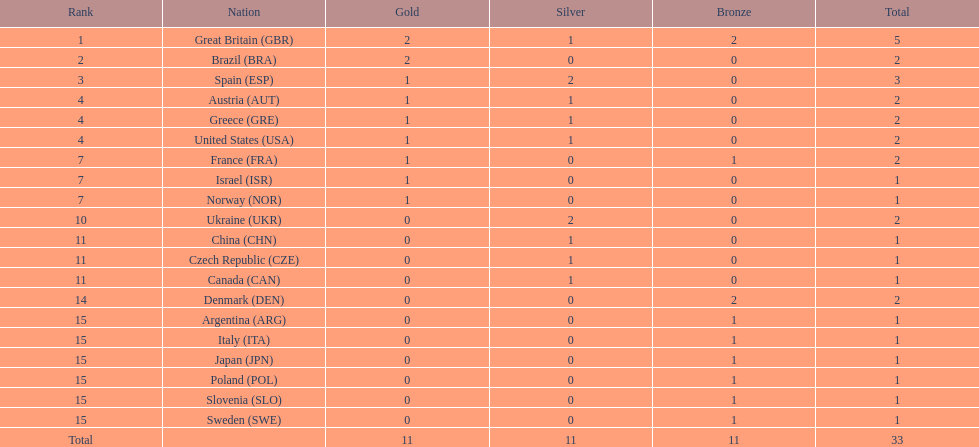In terms of total medals, which nation ranked beside great britain? Spain. 